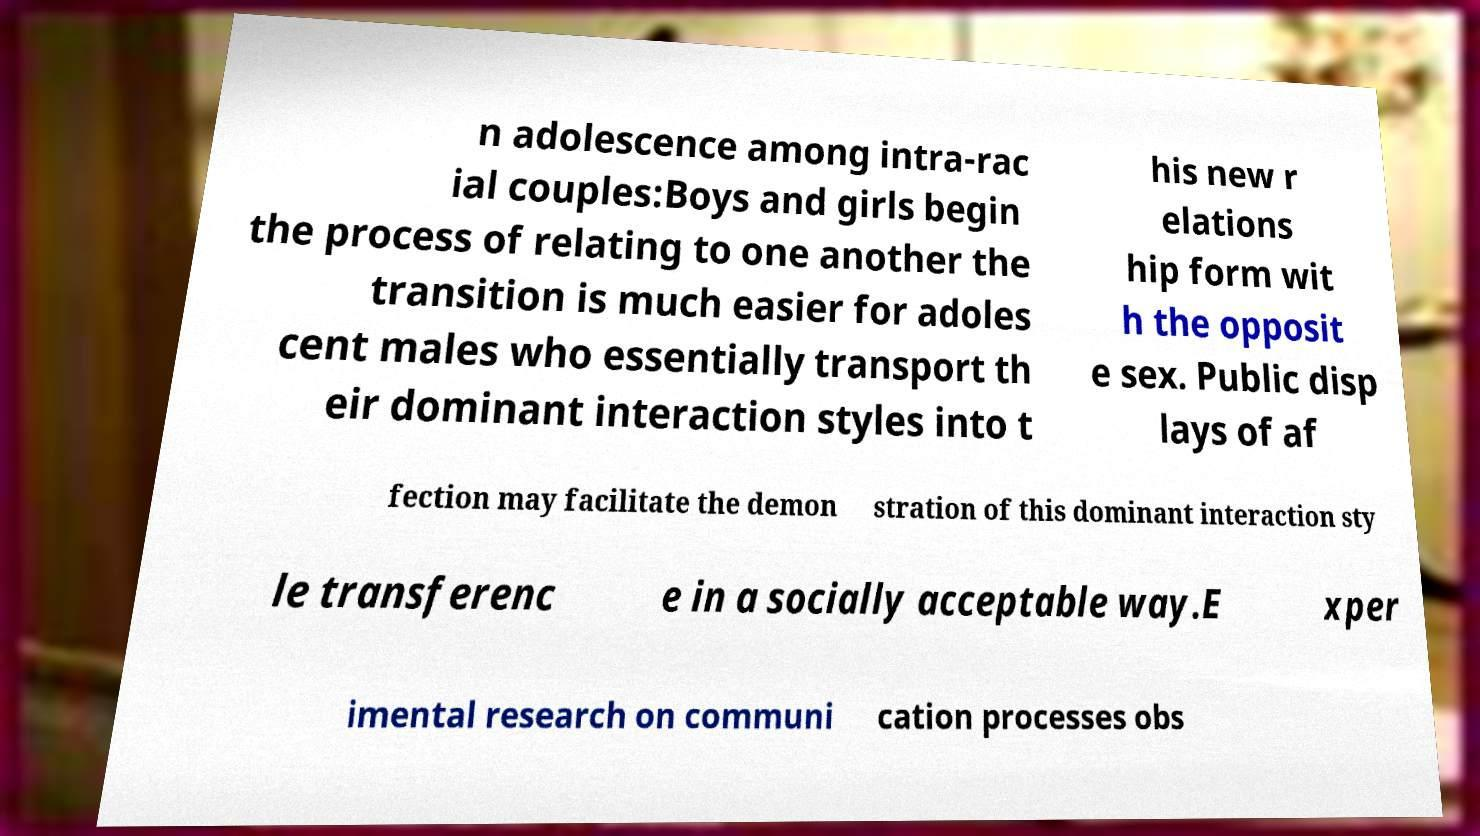Can you read and provide the text displayed in the image?This photo seems to have some interesting text. Can you extract and type it out for me? n adolescence among intra-rac ial couples:Boys and girls begin the process of relating to one another the transition is much easier for adoles cent males who essentially transport th eir dominant interaction styles into t his new r elations hip form wit h the opposit e sex. Public disp lays of af fection may facilitate the demon stration of this dominant interaction sty le transferenc e in a socially acceptable way.E xper imental research on communi cation processes obs 